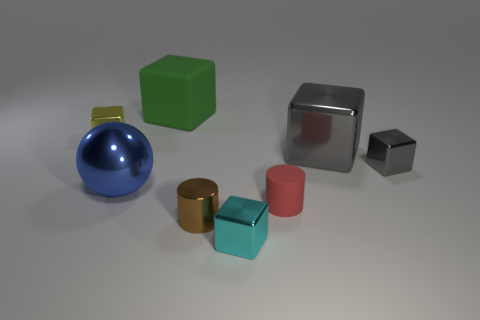There is another block that is the same color as the large shiny cube; what is its size?
Offer a terse response. Small. Are there any other things that are the same size as the ball?
Your response must be concise. Yes. What is the material of the big cube left of the large cube in front of the tiny yellow block?
Make the answer very short. Rubber. What number of rubber things are either blue things or yellow blocks?
Offer a very short reply. 0. There is another big metallic object that is the same shape as the cyan metal thing; what is its color?
Ensure brevity in your answer.  Gray. What number of metallic cubes have the same color as the small matte thing?
Your answer should be very brief. 0. There is a big shiny object on the right side of the tiny brown metal object; are there any tiny yellow blocks in front of it?
Give a very brief answer. No. What number of small objects are both behind the tiny red object and in front of the tiny red rubber cylinder?
Ensure brevity in your answer.  0. What number of other tiny yellow blocks are made of the same material as the small yellow block?
Provide a succinct answer. 0. What is the size of the matte object in front of the big thing that is behind the small yellow shiny cube?
Your answer should be very brief. Small. 